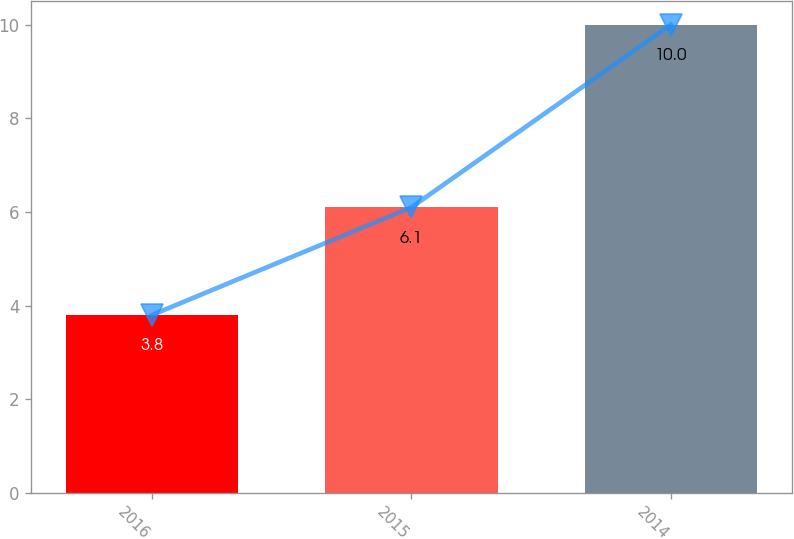Convert chart to OTSL. <chart><loc_0><loc_0><loc_500><loc_500><bar_chart><fcel>2016<fcel>2015<fcel>2014<nl><fcel>3.8<fcel>6.1<fcel>10<nl></chart> 